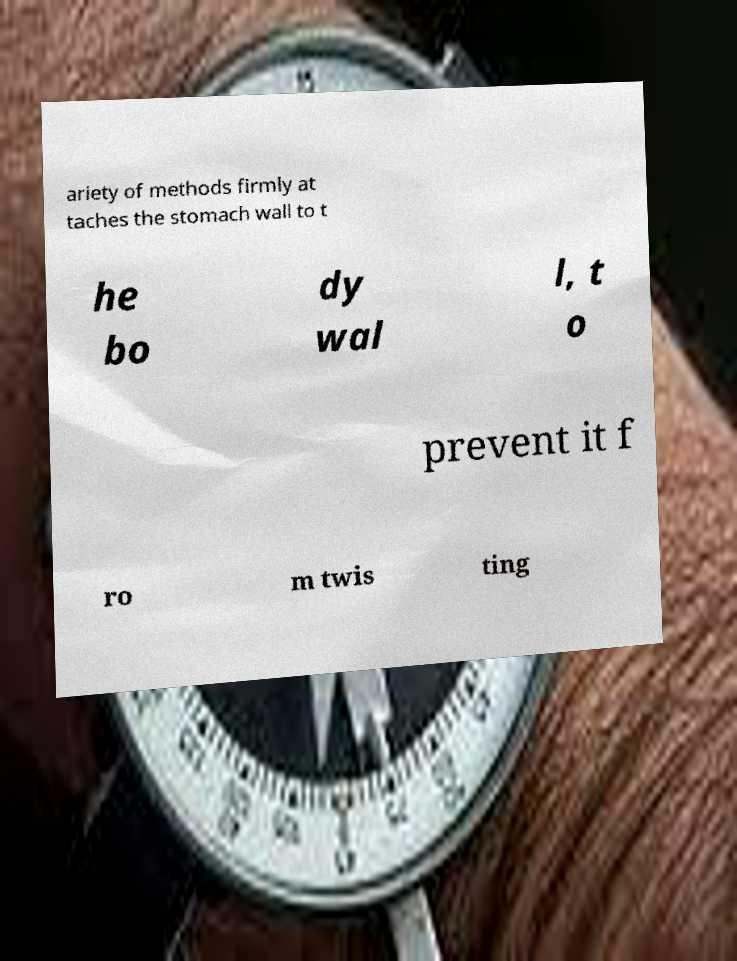There's text embedded in this image that I need extracted. Can you transcribe it verbatim? ariety of methods firmly at taches the stomach wall to t he bo dy wal l, t o prevent it f ro m twis ting 